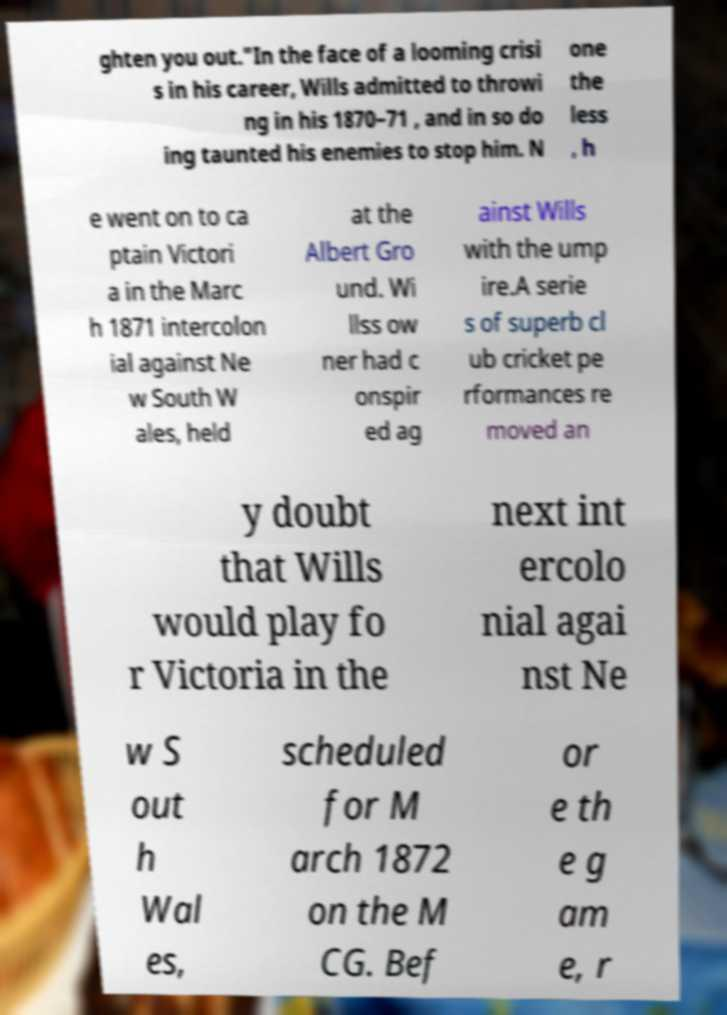Please identify and transcribe the text found in this image. ghten you out."In the face of a looming crisi s in his career, Wills admitted to throwi ng in his 1870–71 , and in so do ing taunted his enemies to stop him. N one the less , h e went on to ca ptain Victori a in the Marc h 1871 intercolon ial against Ne w South W ales, held at the Albert Gro und. Wi llss ow ner had c onspir ed ag ainst Wills with the ump ire.A serie s of superb cl ub cricket pe rformances re moved an y doubt that Wills would play fo r Victoria in the next int ercolo nial agai nst Ne w S out h Wal es, scheduled for M arch 1872 on the M CG. Bef or e th e g am e, r 